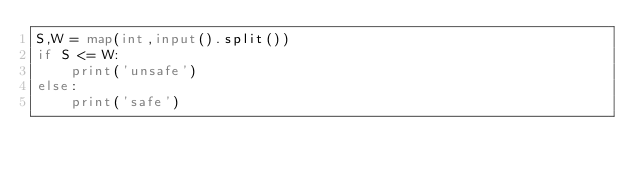<code> <loc_0><loc_0><loc_500><loc_500><_Python_>S,W = map(int,input().split())
if S <= W:
    print('unsafe')
else:
    print('safe')</code> 